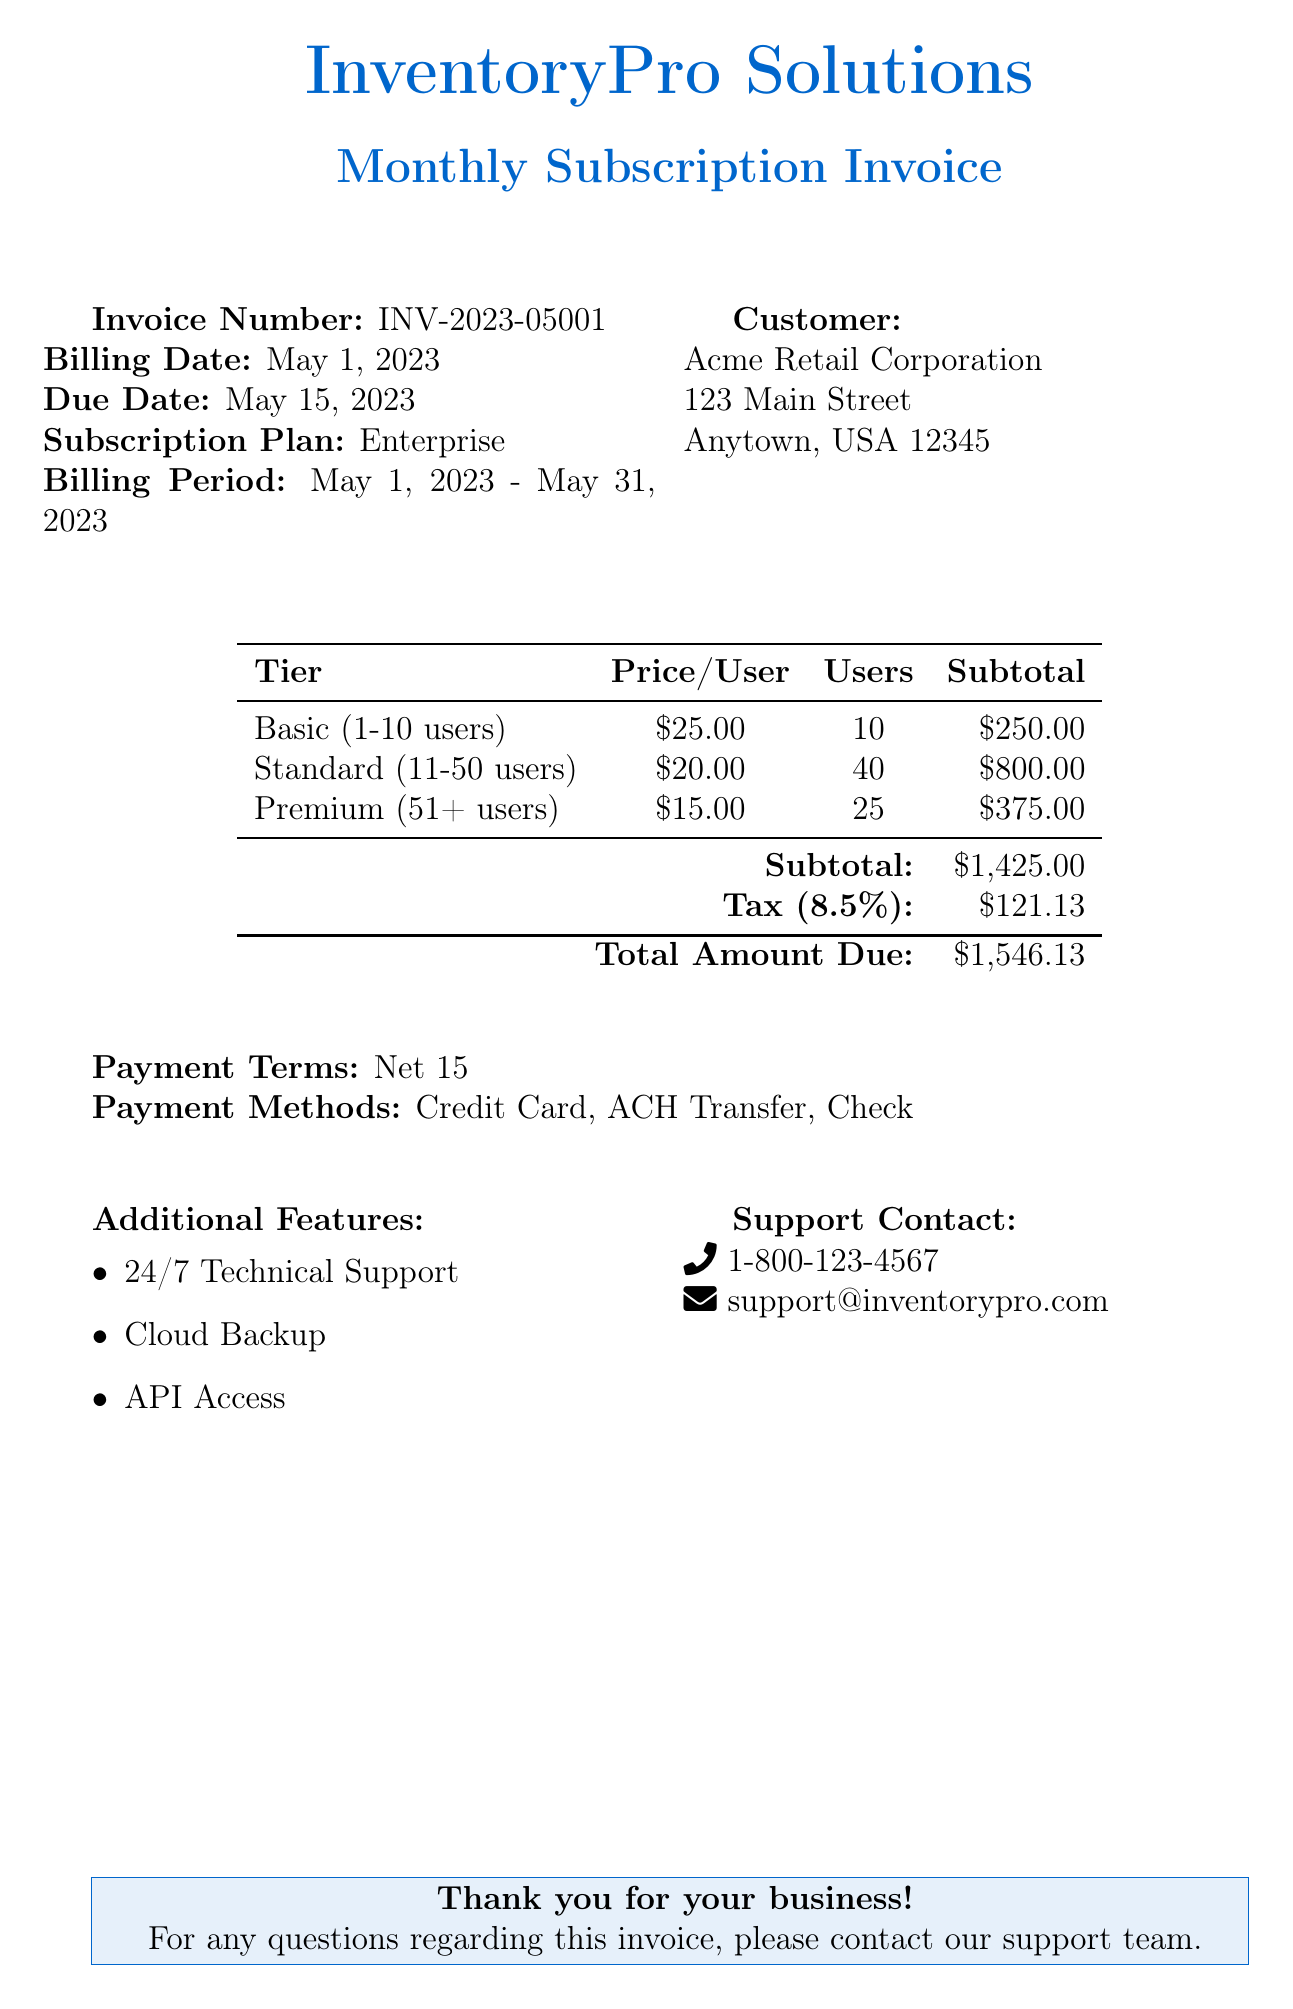What is the invoice number? The invoice number is listed prominently in the document, allowing for easy reference to this specific billing instance.
Answer: INV-2023-05001 What is the billing date? The billing date provides the day the invoice was generated, which is critical for payment tracking.
Answer: May 1, 2023 What is the total amount due? The total amount due is the final amount owed after calculations of subs and taxes have been completed.
Answer: $1,546.13 How many users are in the Premium tier? The document specifies the number of users in each tier, which is important for understanding the pricing structure.
Answer: 25 What is the tax rate applied? The tax rate is indicated in the document and is essential for calculating the total amount due.
Answer: 8.5% What payment terms are specified? Payment terms outline the time frame required for payment, which is necessary for financial clarity.
Answer: Net 15 What subscription plan is listed? The subscription plan details the level of service being utilized, which may affect the features available.
Answer: Enterprise What features are included in the subscription? The additional features give customers insights into what services they can expect from their subscription.
Answer: 24/7 Technical Support, Cloud Backup, API Access What payment methods are accepted? Knowing the available payment methods is critical for customers to plan how they will pay their invoice.
Answer: Credit Card, ACH Transfer, Check 